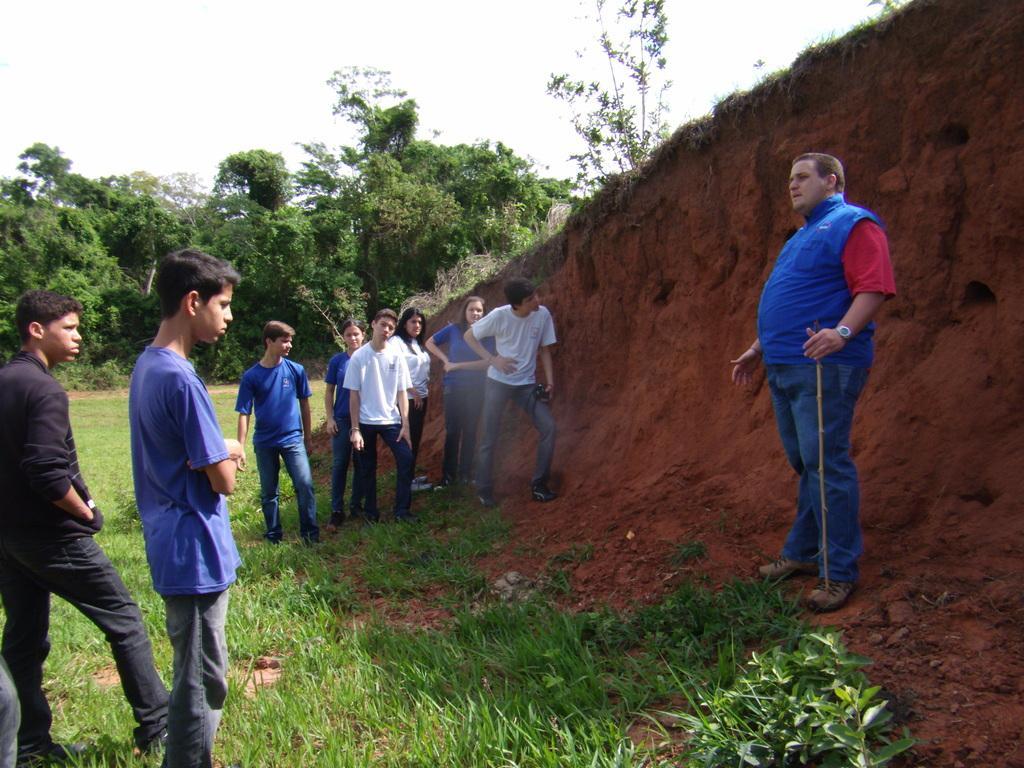Please provide a concise description of this image. In this image we can see a few people standing, among them two are holding the objects, there are some trees, grass and mud, in the background we can see the sky. 